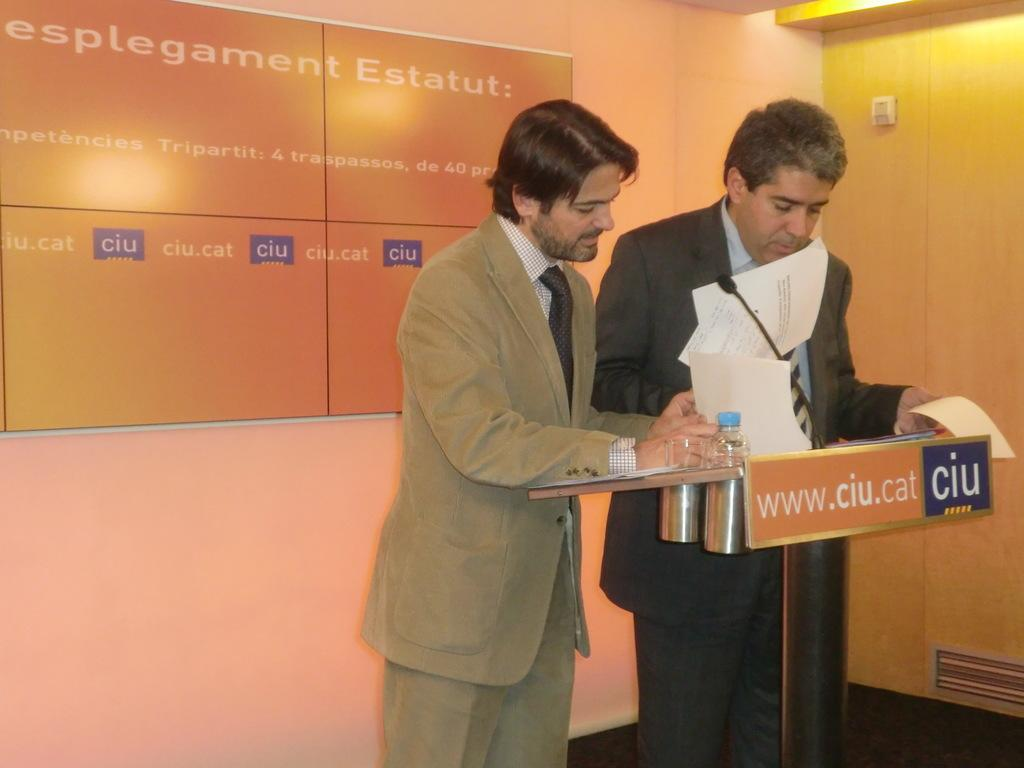How many people are in the image? There are two men standing in the image. What object is present in the image that is typically used for speeches or presentations? There is a podium in the image. What device is used for amplifying sound in the image? A microphone is present in the image. What item can be seen in the image that might be used for hydration? There is a water bottle in the image. What can be seen in the background of the image? There is a wall visible in the background of the image. What type of snails can be seen crawling on the podium in the image? There are no snails present in the image; the podium is empty except for the microphone. 